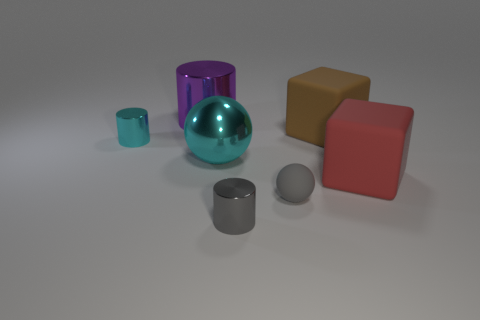How many other things are there of the same shape as the tiny gray matte object?
Your response must be concise. 1. How many shiny objects are small cyan things or large red cubes?
Make the answer very short. 1. There is a tiny thing that is to the right of the shiny cylinder that is in front of the small cyan cylinder; what is its material?
Provide a short and direct response. Rubber. Are there more rubber spheres that are in front of the gray cylinder than tiny red matte blocks?
Ensure brevity in your answer.  No. Are there any blocks made of the same material as the big cylinder?
Make the answer very short. No. There is a tiny metal thing behind the tiny gray rubber sphere; is its shape the same as the gray metal object?
Provide a succinct answer. Yes. What number of big brown cubes are left of the cube that is to the left of the large rubber thing that is right of the brown matte thing?
Offer a terse response. 0. Are there fewer small gray cylinders to the left of the large cyan sphere than gray objects on the left side of the matte ball?
Provide a succinct answer. Yes. There is another large rubber object that is the same shape as the large brown matte thing; what color is it?
Your response must be concise. Red. The cyan shiny ball is what size?
Offer a very short reply. Large. 